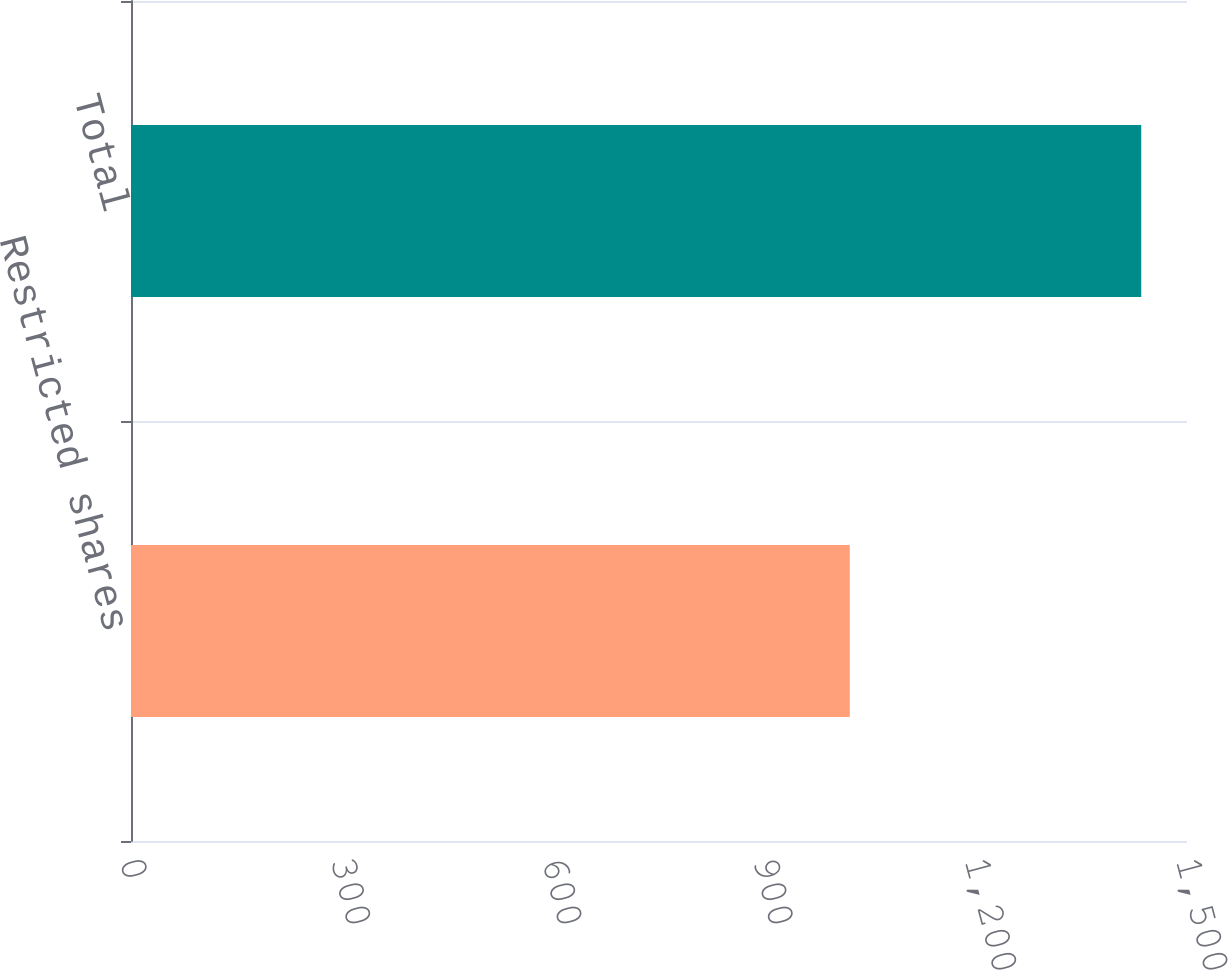Convert chart to OTSL. <chart><loc_0><loc_0><loc_500><loc_500><bar_chart><fcel>Restricted shares<fcel>Total<nl><fcel>1021<fcel>1435<nl></chart> 